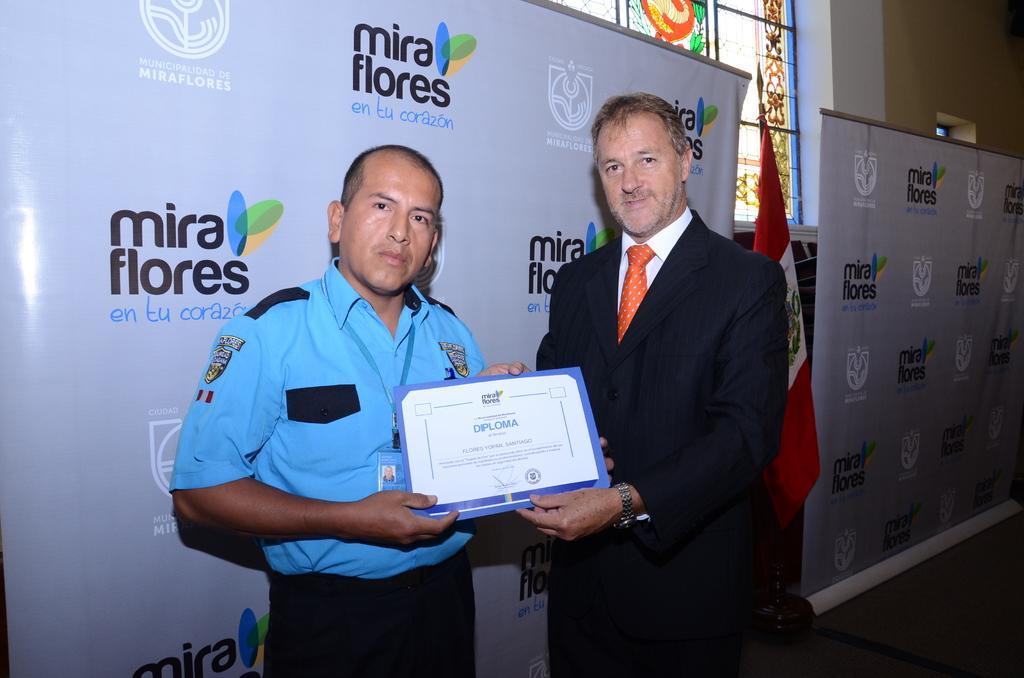Please provide a concise description of this image. In this image we can see the two people and holding an object, some written text on the board, beside there is a flag, we can see the window with an antique painting. 